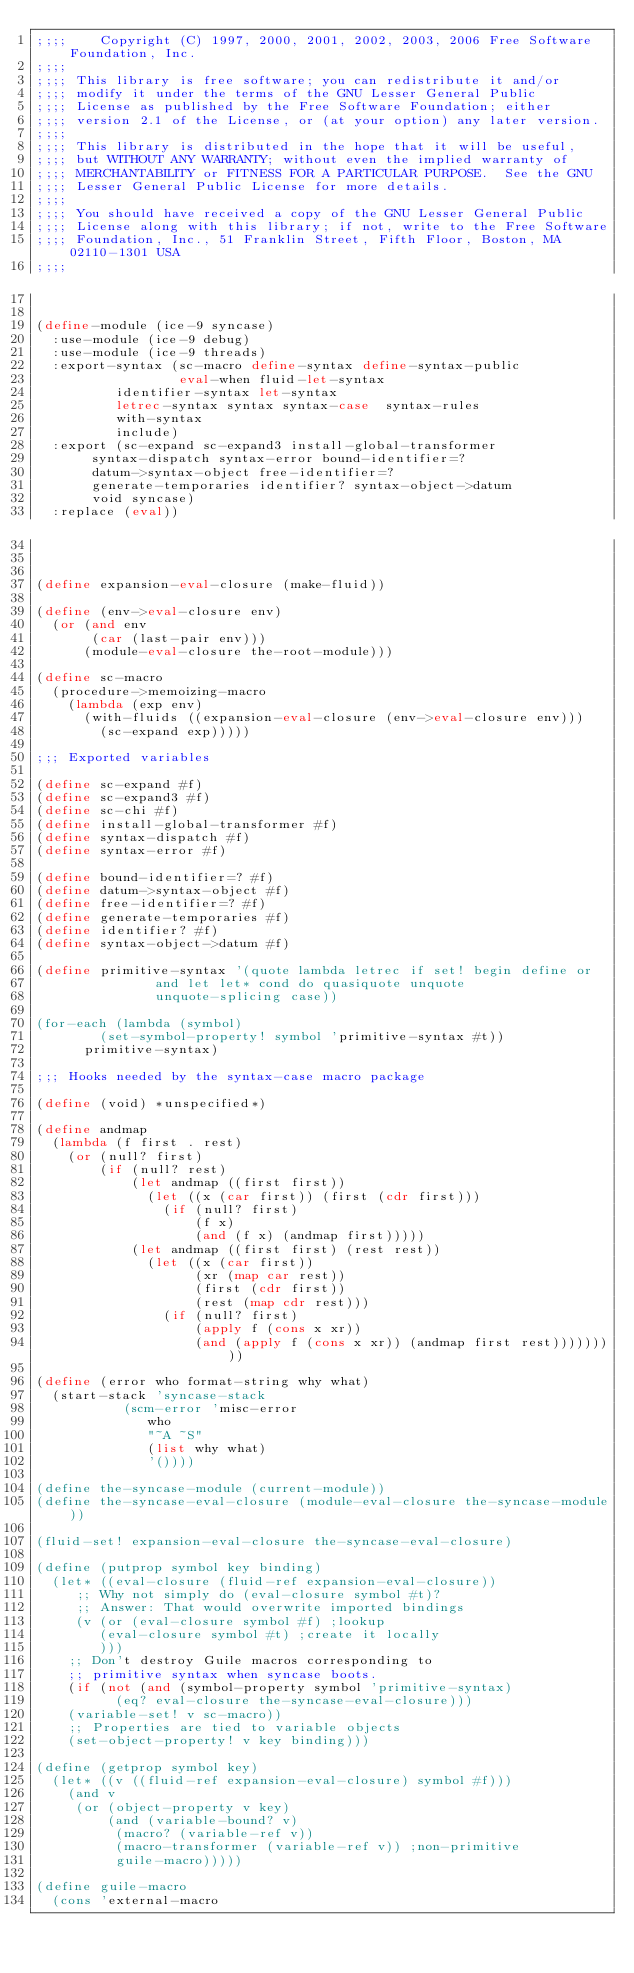<code> <loc_0><loc_0><loc_500><loc_500><_Scheme_>;;;; 	Copyright (C) 1997, 2000, 2001, 2002, 2003, 2006 Free Software Foundation, Inc.
;;;; 
;;;; This library is free software; you can redistribute it and/or
;;;; modify it under the terms of the GNU Lesser General Public
;;;; License as published by the Free Software Foundation; either
;;;; version 2.1 of the License, or (at your option) any later version.
;;;; 
;;;; This library is distributed in the hope that it will be useful,
;;;; but WITHOUT ANY WARRANTY; without even the implied warranty of
;;;; MERCHANTABILITY or FITNESS FOR A PARTICULAR PURPOSE.  See the GNU
;;;; Lesser General Public License for more details.
;;;; 
;;;; You should have received a copy of the GNU Lesser General Public
;;;; License along with this library; if not, write to the Free Software
;;;; Foundation, Inc., 51 Franklin Street, Fifth Floor, Boston, MA 02110-1301 USA
;;;; 


(define-module (ice-9 syncase)
  :use-module (ice-9 debug)
  :use-module (ice-9 threads)
  :export-syntax (sc-macro define-syntax define-syntax-public 
                  eval-when fluid-let-syntax
		  identifier-syntax let-syntax
		  letrec-syntax syntax syntax-case  syntax-rules
		  with-syntax
		  include)
  :export (sc-expand sc-expand3 install-global-transformer
	   syntax-dispatch syntax-error bound-identifier=?
	   datum->syntax-object free-identifier=?
	   generate-temporaries identifier? syntax-object->datum
	   void syncase)
  :replace (eval))



(define expansion-eval-closure (make-fluid))

(define (env->eval-closure env)
  (or (and env
	   (car (last-pair env)))
      (module-eval-closure the-root-module)))

(define sc-macro
  (procedure->memoizing-macro
    (lambda (exp env)
      (with-fluids ((expansion-eval-closure (env->eval-closure env)))
        (sc-expand exp)))))

;;; Exported variables

(define sc-expand #f)
(define sc-expand3 #f)
(define sc-chi #f)
(define install-global-transformer #f)
(define syntax-dispatch #f)
(define syntax-error #f)

(define bound-identifier=? #f)
(define datum->syntax-object #f)
(define free-identifier=? #f)
(define generate-temporaries #f)
(define identifier? #f)
(define syntax-object->datum #f)

(define primitive-syntax '(quote lambda letrec if set! begin define or
			   and let let* cond do quasiquote unquote
			   unquote-splicing case))

(for-each (lambda (symbol)
	    (set-symbol-property! symbol 'primitive-syntax #t))
	  primitive-syntax)

;;; Hooks needed by the syntax-case macro package

(define (void) *unspecified*)

(define andmap
  (lambda (f first . rest)
    (or (null? first)
        (if (null? rest)
            (let andmap ((first first))
              (let ((x (car first)) (first (cdr first)))
                (if (null? first)
                    (f x)
                    (and (f x) (andmap first)))))
            (let andmap ((first first) (rest rest))
              (let ((x (car first))
                    (xr (map car rest))
                    (first (cdr first))
                    (rest (map cdr rest)))
                (if (null? first)
                    (apply f (cons x xr))
                    (and (apply f (cons x xr)) (andmap first rest)))))))))

(define (error who format-string why what)
  (start-stack 'syncase-stack
	       (scm-error 'misc-error
			  who
			  "~A ~S"
			  (list why what)
			  '())))

(define the-syncase-module (current-module))
(define the-syncase-eval-closure (module-eval-closure the-syncase-module))

(fluid-set! expansion-eval-closure the-syncase-eval-closure)

(define (putprop symbol key binding)
  (let* ((eval-closure (fluid-ref expansion-eval-closure))
	 ;; Why not simply do (eval-closure symbol #t)?
	 ;; Answer: That would overwrite imported bindings
	 (v (or (eval-closure symbol #f) ;lookup
		(eval-closure symbol #t) ;create it locally
		)))
    ;; Don't destroy Guile macros corresponding to
    ;; primitive syntax when syncase boots.
    (if (not (and (symbol-property symbol 'primitive-syntax)
		  (eq? eval-closure the-syncase-eval-closure)))
	(variable-set! v sc-macro))
    ;; Properties are tied to variable objects
    (set-object-property! v key binding)))

(define (getprop symbol key)
  (let* ((v ((fluid-ref expansion-eval-closure) symbol #f)))
    (and v
	 (or (object-property v key)
	     (and (variable-bound? v)
		  (macro? (variable-ref v))
		  (macro-transformer (variable-ref v)) ;non-primitive
		  guile-macro)))))

(define guile-macro
  (cons 'external-macro</code> 